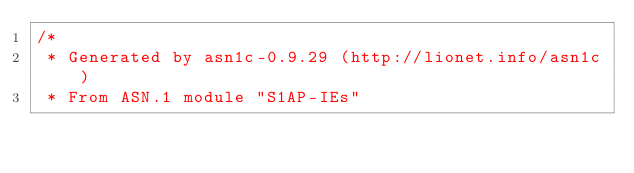Convert code to text. <code><loc_0><loc_0><loc_500><loc_500><_C_>/*
 * Generated by asn1c-0.9.29 (http://lionet.info/asn1c)
 * From ASN.1 module "S1AP-IEs"</code> 